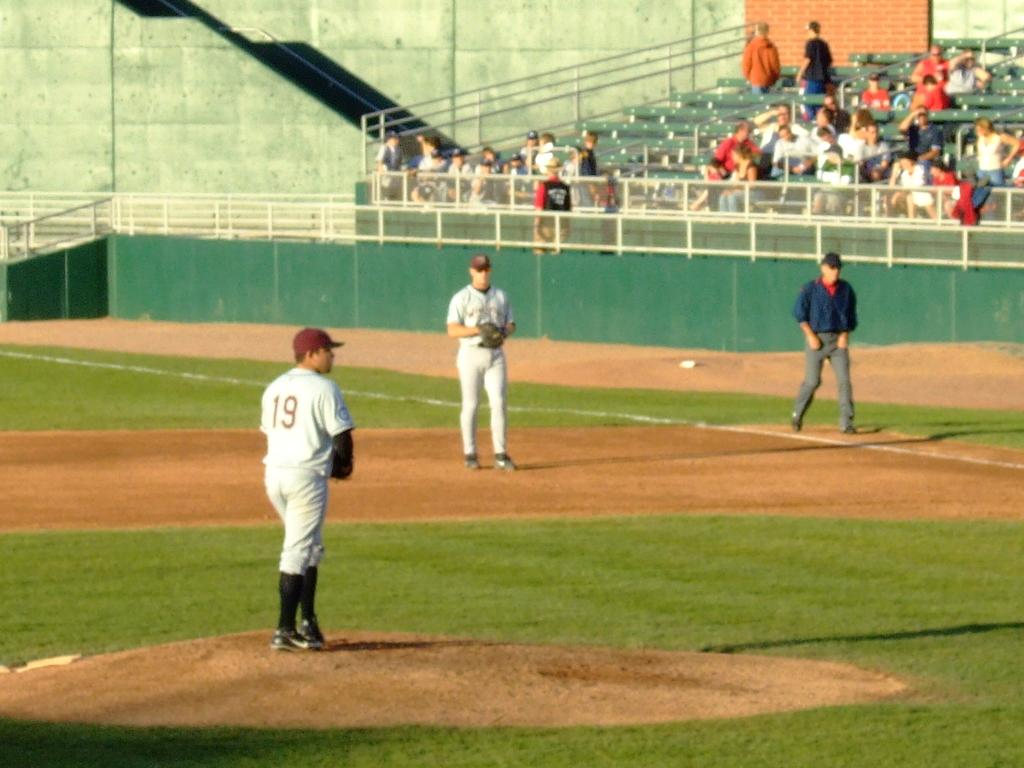<image>
Summarize the visual content of the image. number 19 getting ready to pitch baseball in front of sparse crowd 